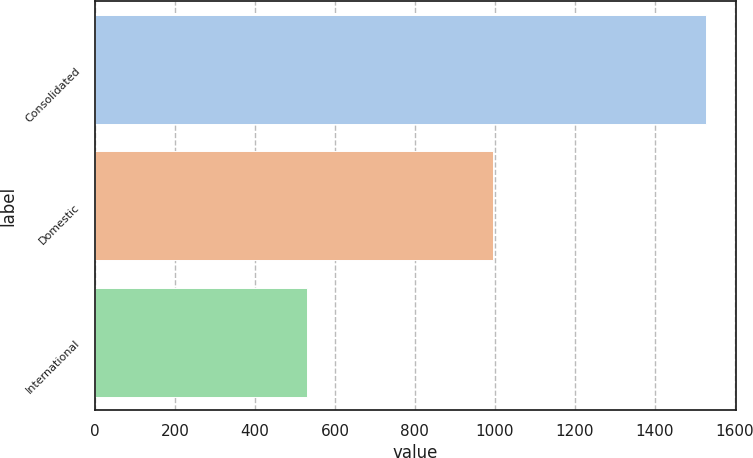Convert chart. <chart><loc_0><loc_0><loc_500><loc_500><bar_chart><fcel>Consolidated<fcel>Domestic<fcel>International<nl><fcel>1527.2<fcel>996.1<fcel>531.1<nl></chart> 